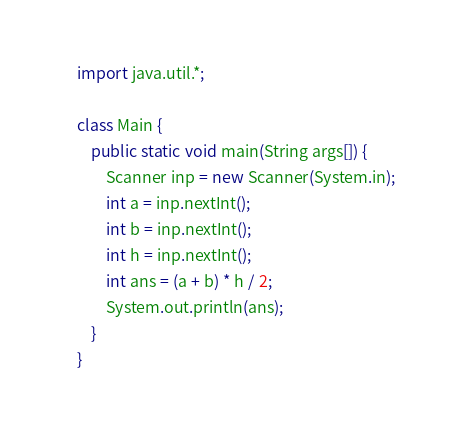Convert code to text. <code><loc_0><loc_0><loc_500><loc_500><_Java_>import java.util.*;

class Main {
    public static void main(String args[]) {
        Scanner inp = new Scanner(System.in);
        int a = inp.nextInt();
        int b = inp.nextInt();
        int h = inp.nextInt();
        int ans = (a + b) * h / 2;
        System.out.println(ans);
    }
}</code> 